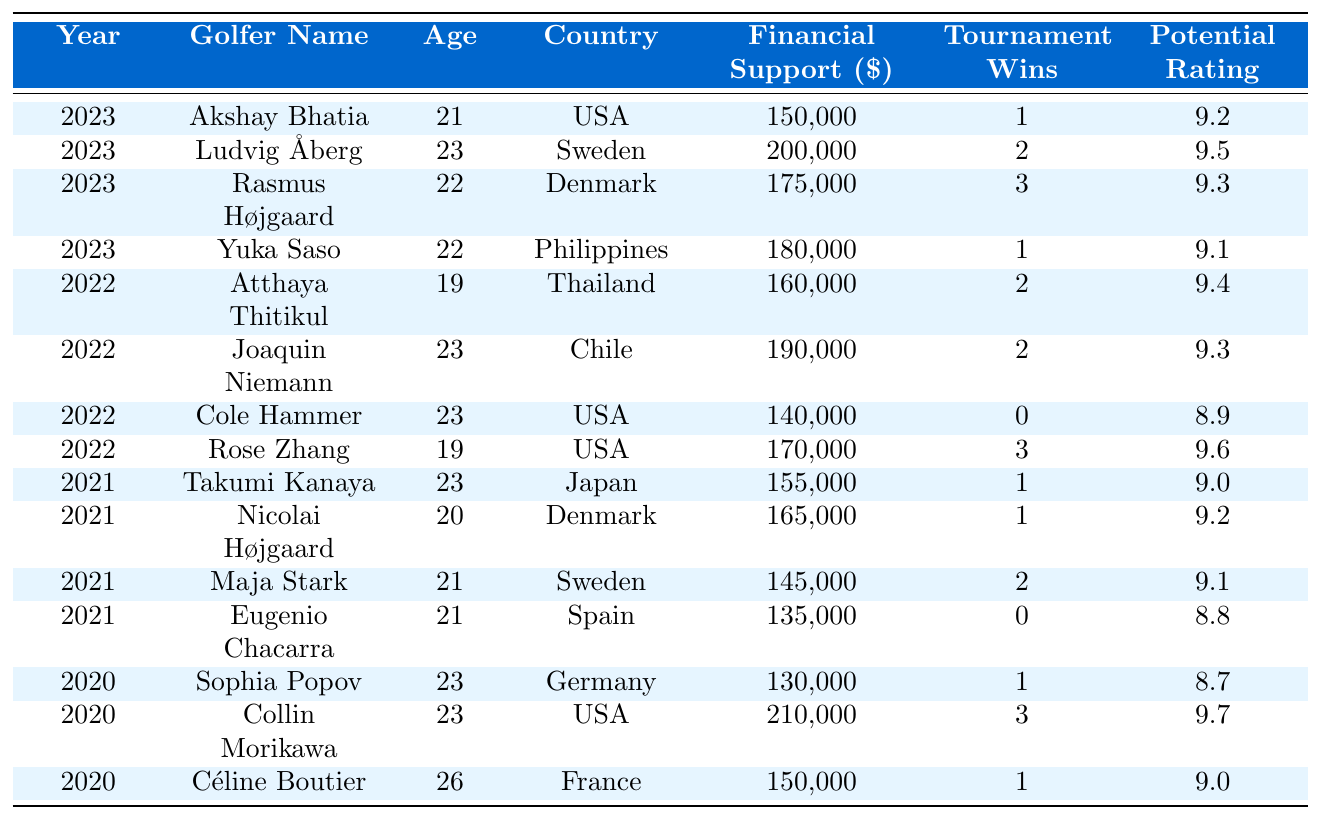What is the total financial support provided to golfers in 2023? In 2023, the financial support allocations for the golfers are: 150000 (Akshay Bhatia) + 200000 (Ludvig Åberg) + 175000 (Rasmus Højgaard) + 180000 (Yuka Saso) = 705000.
Answer: 705000 Which golfer had the highest financial support in 2022? In 2022, the financial support amounts are: 160000 (Atthaya Thitikul), 190000 (Joaquin Niemann), 140000 (Cole Hammer), 170000 (Rose Zhang). The highest is 190000 for Joaquin Niemann.
Answer: Joaquin Niemann How many tournament wins does Rasmus Højgaard have? Rasmus Højgaard has 3 tournament wins, as shown in the table under the "Tournament Wins" column for the year 2023.
Answer: 3 What age is the oldest golfer listed in the table? The ages of the golfers are: 21 (Akshay Bhatia), 23 (Ludvig Åberg), 22 (Rasmus Højgaard), 22 (Yuka Saso), 19 (Atthaya Thitikul), 23 (Joaquin Niemann), 23 (Cole Hammer), 19 (Rose Zhang), 23 (Takumi Kanaya), 20 (Nicolai Højgaard), 21 (Maja Stark), 21 (Eugenio Chacarra), 23 (Sophia Popov), 23 (Collin Morikawa), 26 (Céline Boutier). The oldest age is 26 for Céline Boutier.
Answer: 26 What is the average financial support provided across all years? Total financial support amounts are: 150000 + 200000 + 175000 + 180000 + 160000 + 190000 + 140000 + 170000 + 155000 + 165000 + 145000 + 135000 + 130000 + 210000 + 150000 = 2185000. The total number of entries is 15, so the average is 2185000 / 15 = 145666.67.
Answer: 145666.67 Is there a golfer from Thailand listed in the table? Yes, Atthaya Thitikul is from Thailand, confirmed in the "Country" column for the year 2022.
Answer: Yes Which golfer has the highest potential rating in the table? The potential ratings listed are: 9.2 (Akshay Bhatia), 9.5 (Ludvig Åberg), 9.3 (Rasmus Højgaard), 9.1 (Yuka Saso), 9.4 (Atthaya Thitikul), 9.3 (Joaquin Niemann), 8.9 (Cole Hammer), 9.6 (Rose Zhang), 9.0 (Takumi Kanaya), 9.2 (Nicolai Højgaard), 9.1 (Maja Stark), 8.8 (Eugenio Chacarra), 8.7 (Sophia Popov), 9.7 (Collin Morikawa), 9.0 (Céline Boutier). The highest is 9.7 for Collin Morikawa.
Answer: Collin Morikawa What is the total number of tournament wins for golfers supported in 2021? The tournament wins for 2021 are: 1 (Takumi Kanaya) + 1 (Nicolai Højgaard) + 2 (Maja Stark) + 0 (Eugenio Chacarra) = 4.
Answer: 4 Which country had the golfer with the lowest financial support in 2022? In 2022, the financial support amounts are: 160000 (Atthaya Thitikul, Thailand), 190000 (Joaquin Niemann, Chile), 140000 (Cole Hammer, USA), 170000 (Rose Zhang, USA). The lowest is 140000 which is for Cole Hammer from the USA.
Answer: USA What is the difference in financial support between the highest and lowest in 2023? The highest financial support in 2023 is 200000 (Ludvig Åberg) and the lowest is 150000 (Akshay Bhatia). The difference is 200000 - 150000 = 50000.
Answer: 50000 